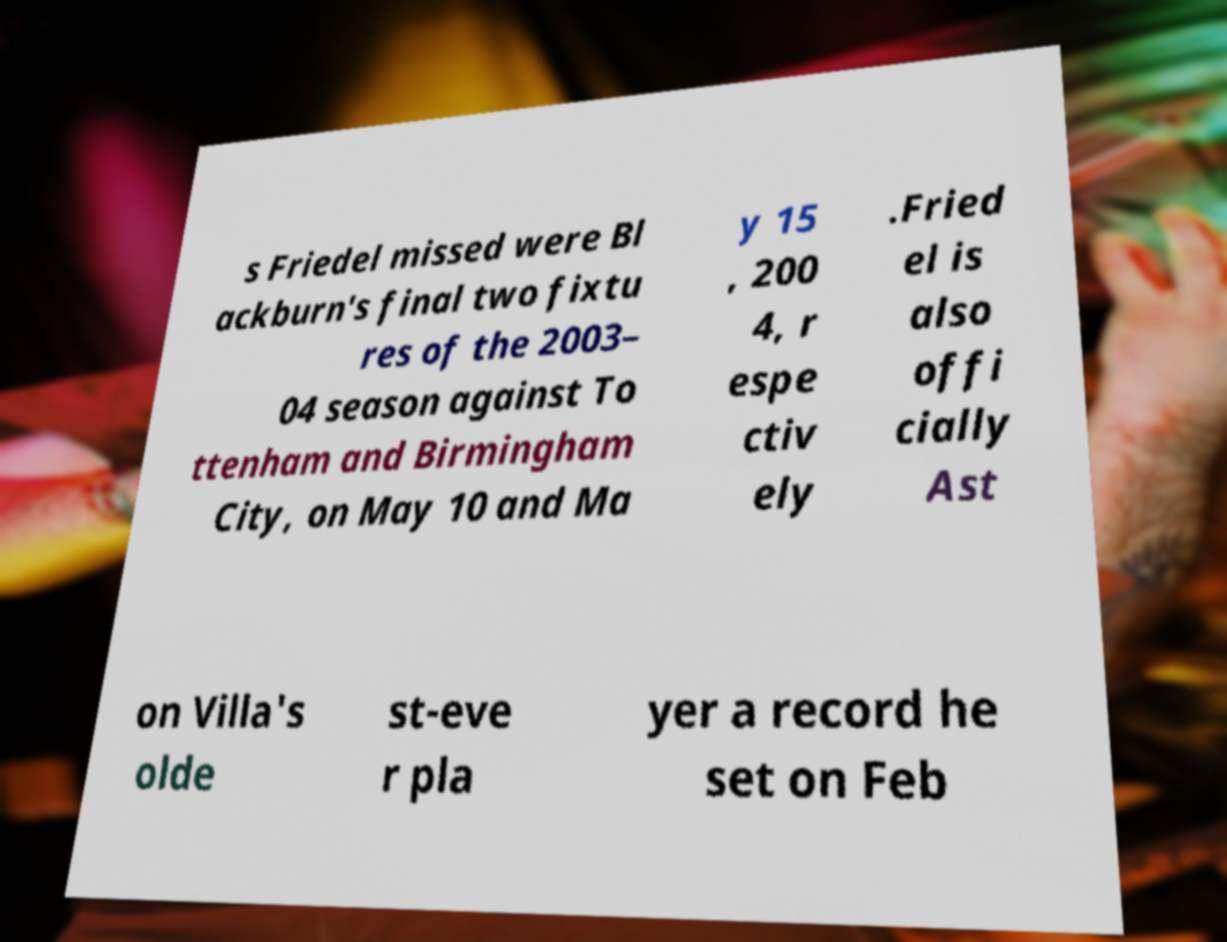For documentation purposes, I need the text within this image transcribed. Could you provide that? s Friedel missed were Bl ackburn's final two fixtu res of the 2003– 04 season against To ttenham and Birmingham City, on May 10 and Ma y 15 , 200 4, r espe ctiv ely .Fried el is also offi cially Ast on Villa's olde st-eve r pla yer a record he set on Feb 